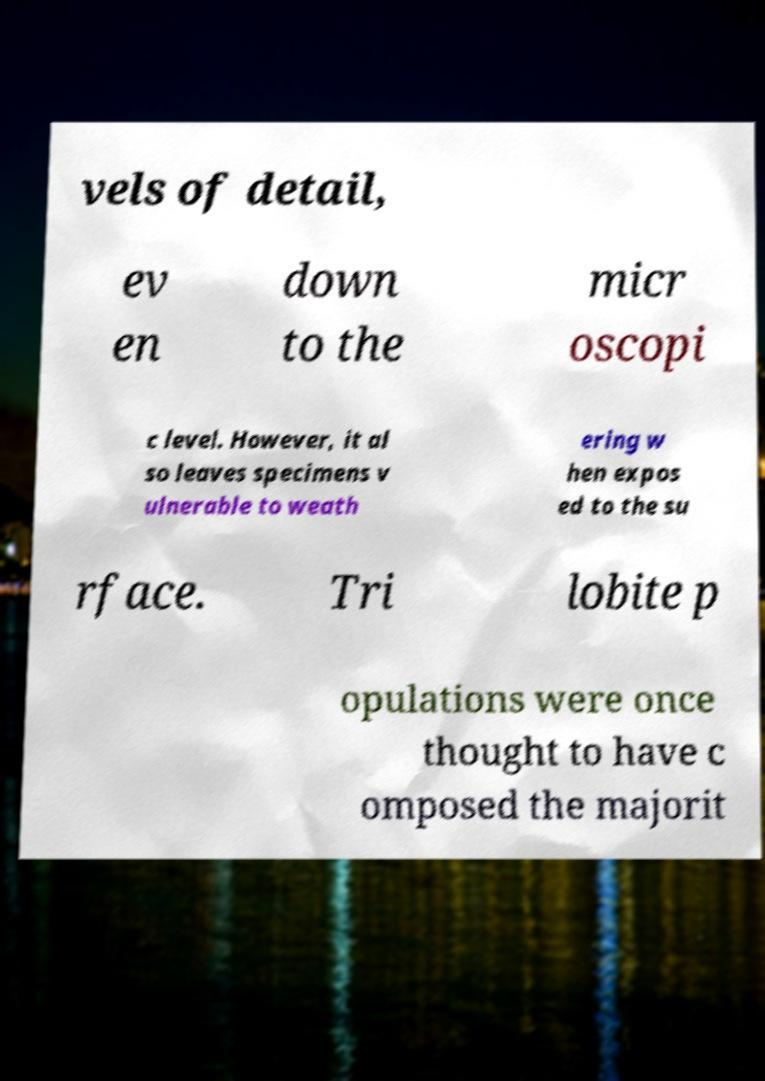Could you assist in decoding the text presented in this image and type it out clearly? vels of detail, ev en down to the micr oscopi c level. However, it al so leaves specimens v ulnerable to weath ering w hen expos ed to the su rface. Tri lobite p opulations were once thought to have c omposed the majorit 